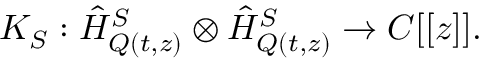<formula> <loc_0><loc_0><loc_500><loc_500>K _ { S } \colon \hat { H } _ { Q ( t , z ) } ^ { S } \otimes \hat { H } _ { Q ( t , z ) } ^ { S } \rightarrow C [ [ z ] ] .</formula> 